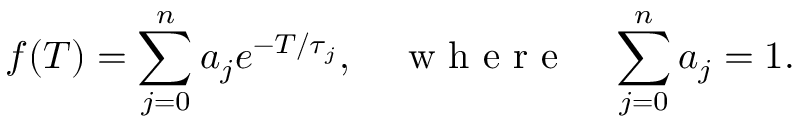<formula> <loc_0><loc_0><loc_500><loc_500>f ( T ) = \sum _ { j = 0 } ^ { n } a _ { j } e ^ { - T / \tau _ { j } } , \quad w h e r e \quad \sum _ { j = 0 } ^ { n } a _ { j } = 1 .</formula> 